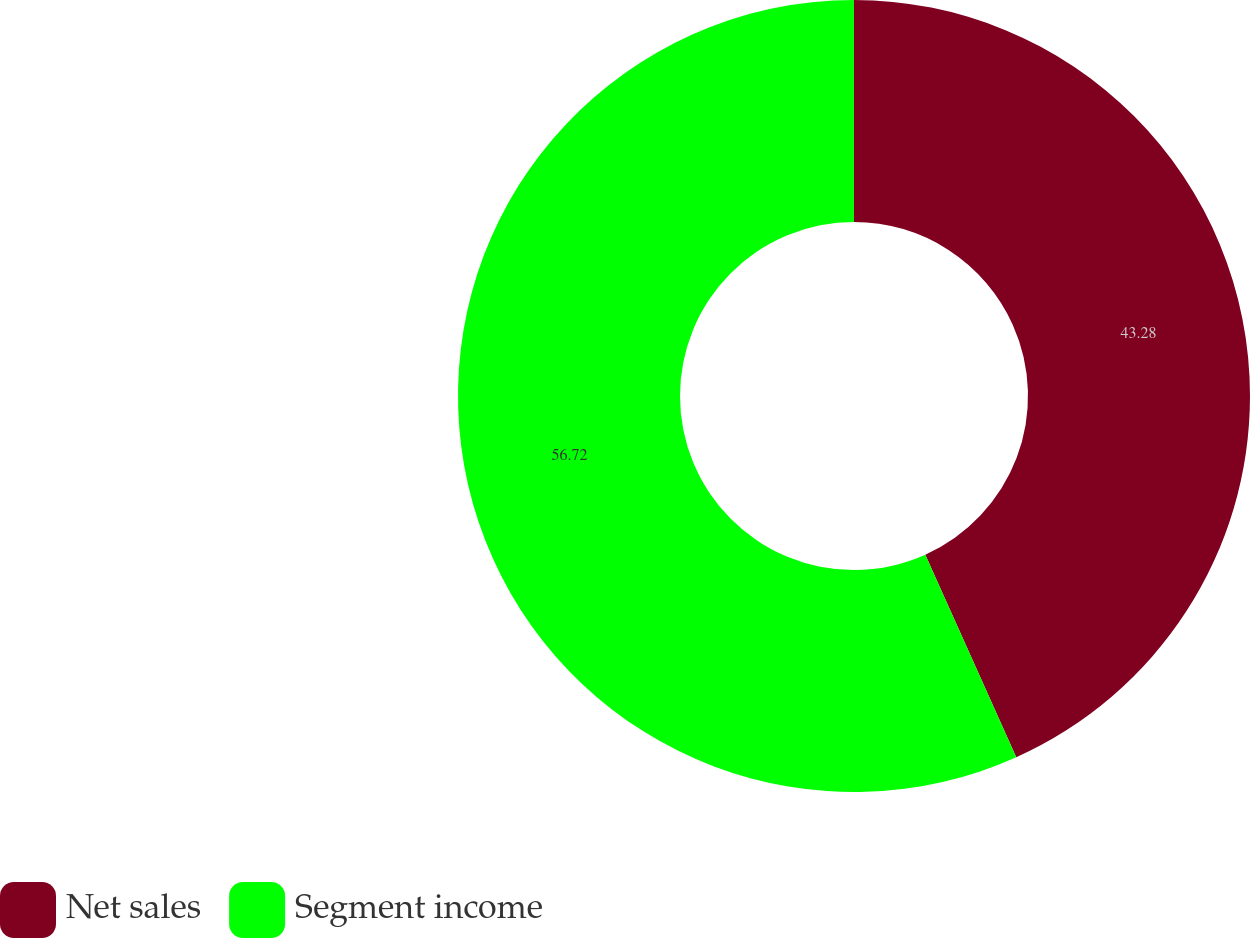Convert chart to OTSL. <chart><loc_0><loc_0><loc_500><loc_500><pie_chart><fcel>Net sales<fcel>Segment income<nl><fcel>43.28%<fcel>56.72%<nl></chart> 